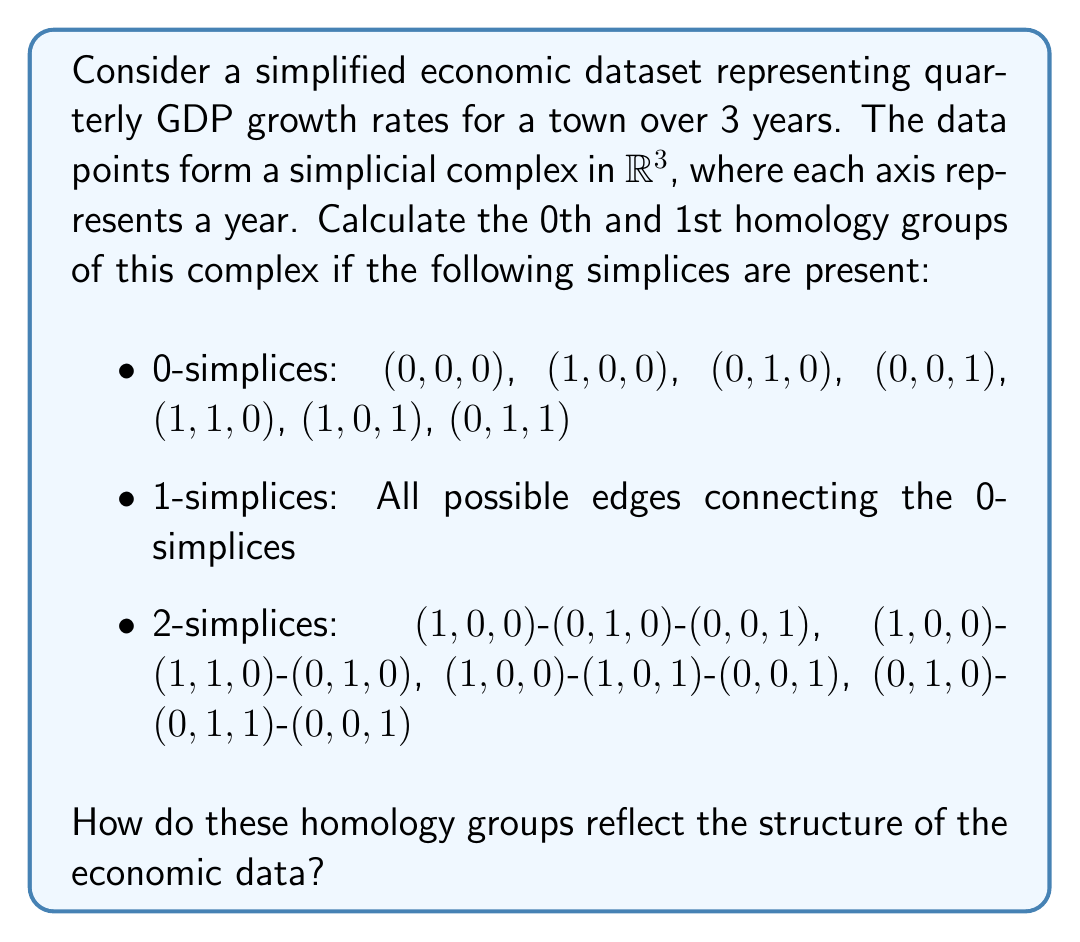Help me with this question. To solve this problem, we need to follow these steps:

1) First, let's understand what the simplicial complex represents:
   - Each point (0-simplex) represents a year's GDP growth rate.
   - Edges (1-simplices) represent connections between years.
   - 2-simplices represent relationships between three years.

2) To calculate the homology groups, we need to determine:
   - $n_0$: number of 0-simplices
   - $n_1$: number of 1-simplices
   - $n_2$: number of 2-simplices
   - $\text{rank}(\partial_1)$: rank of the boundary operator from 1-simplices to 0-simplices
   - $\text{rank}(\partial_2)$: rank of the boundary operator from 2-simplices to 1-simplices

3) From the given information:
   - $n_0 = 7$
   - $n_1 = \binom{7}{2} = 21$ (all possible edges)
   - $n_2 = 4$

4) To find $\text{rank}(\partial_1)$, we need to consider the spanning tree of the 1-skeleton:
   - A spanning tree will have 6 edges (one less than the number of vertices)
   - Therefore, $\text{rank}(\partial_1) = 6$

5) To find $\text{rank}(\partial_2)$, we need to consider the linear independence of the 2-simplices:
   - The 4 given 2-simplices are linearly independent
   - Therefore, $\text{rank}(\partial_2) = 4$

6) Now we can calculate the Betti numbers:
   - $\beta_0 = n_0 - \text{rank}(\partial_1) = 7 - 6 = 1$
   - $\beta_1 = n_1 - \text{rank}(\partial_1) - \text{rank}(\partial_2) = 21 - 6 - 4 = 11$

7) The homology groups are:
   - $H_0 \cong \mathbb{Z}$
   - $H_1 \cong \mathbb{Z}^{11}$

These homology groups reflect the structure of the economic data as follows:

- $H_0$ being $\mathbb{Z}$ indicates that the data forms a single connected component, suggesting overall coherence in the GDP growth rates over the 3-year period.
- $H_1$ being $\mathbb{Z}^{11}$ indicates the presence of 11 loops or cycles in the data. This suggests complex relationships between different years' growth rates, potentially indicating recurring patterns or cyclical behavior in the town's economy.
Answer: The homology groups are:
$H_0 \cong \mathbb{Z}$
$H_1 \cong \mathbb{Z}^{11}$

These groups indicate a single connected component in the data and 11 loops or cycles, suggesting complex relationships and potential recurring patterns in the town's economic indicators over the 3-year period. 